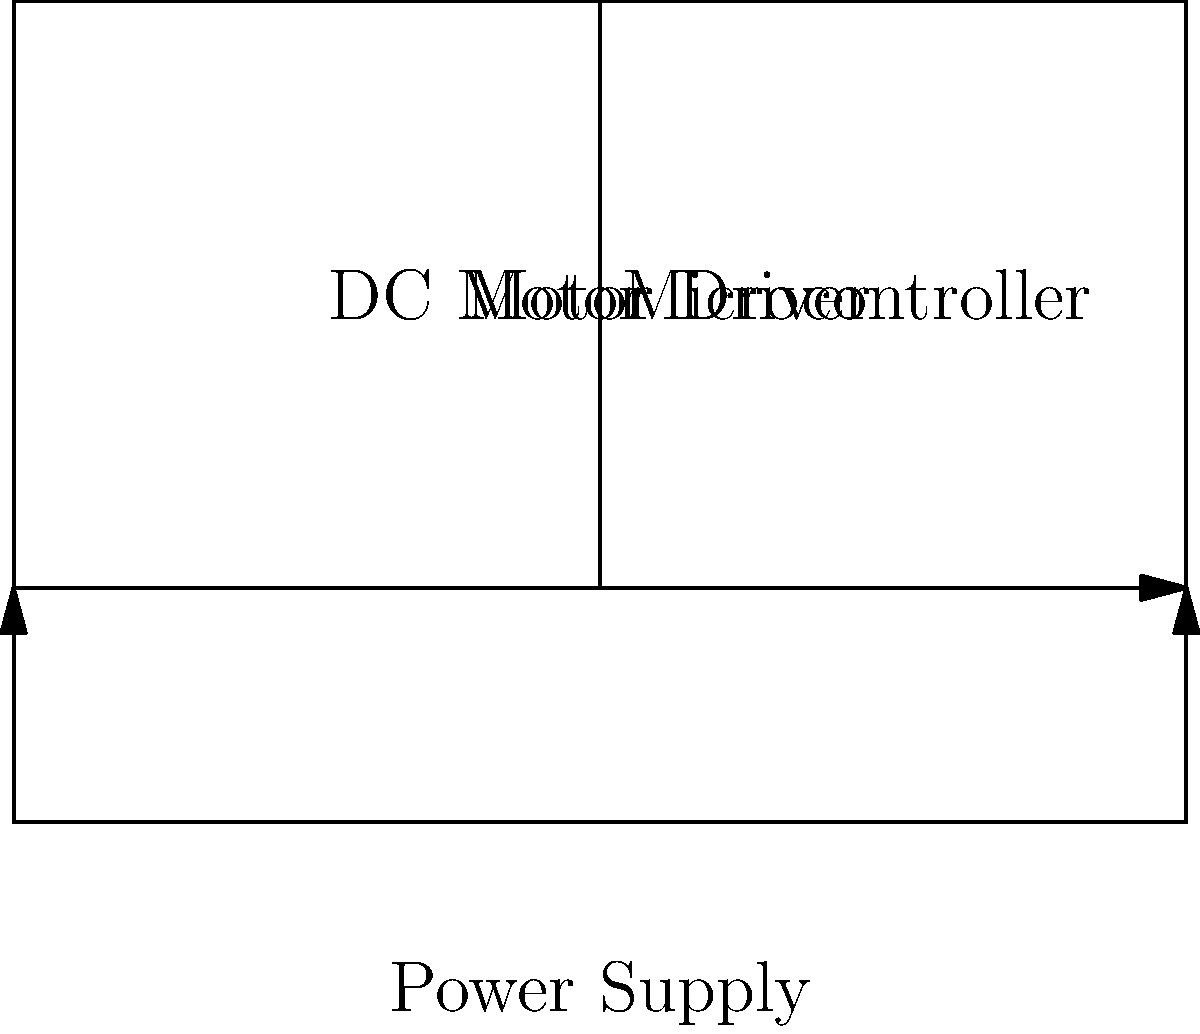In the given circuit diagram for a basic robot control system, what is the primary function of the component labeled "Motor Driver" in relation to the Microcontroller and DC Motor? To understand the function of the Motor Driver in this circuit, let's break down the components and their relationships:

1. Microcontroller: This is the brain of the robot control system. It processes information and sends control signals to other components.

2. DC Motor: This is the actuator that converts electrical energy into mechanical motion, allowing the robot to move.

3. Motor Driver: This is the intermediate component between the Microcontroller and the DC Motor.

The Motor Driver's primary functions are:

a) Amplification: The Microcontroller typically outputs low-power signals (usually 3.3V or 5V) that are not sufficient to drive the DC Motor directly. The Motor Driver amplifies these signals to provide the necessary voltage and current to power the motor.

b) Current handling: DC Motors often require more current than a Microcontroller can safely provide. The Motor Driver can handle these higher currents.

c) Bi-directional control: Most Motor Drivers allow for reversing the direction of the motor by changing the polarity of the voltage applied to the motor.

d) PWM interpretation: If the Microcontroller sends Pulse Width Modulation (PWM) signals, the Motor Driver can interpret these to control the speed of the motor.

e) Protection: Motor Drivers often include protection circuits to prevent damage from voltage spikes or excessive current draw.

In essence, the Motor Driver acts as an interface that allows the low-power Microcontroller to effectively control the high-power DC Motor.
Answer: Amplify and control signals from the Microcontroller to power and manage the DC Motor. 